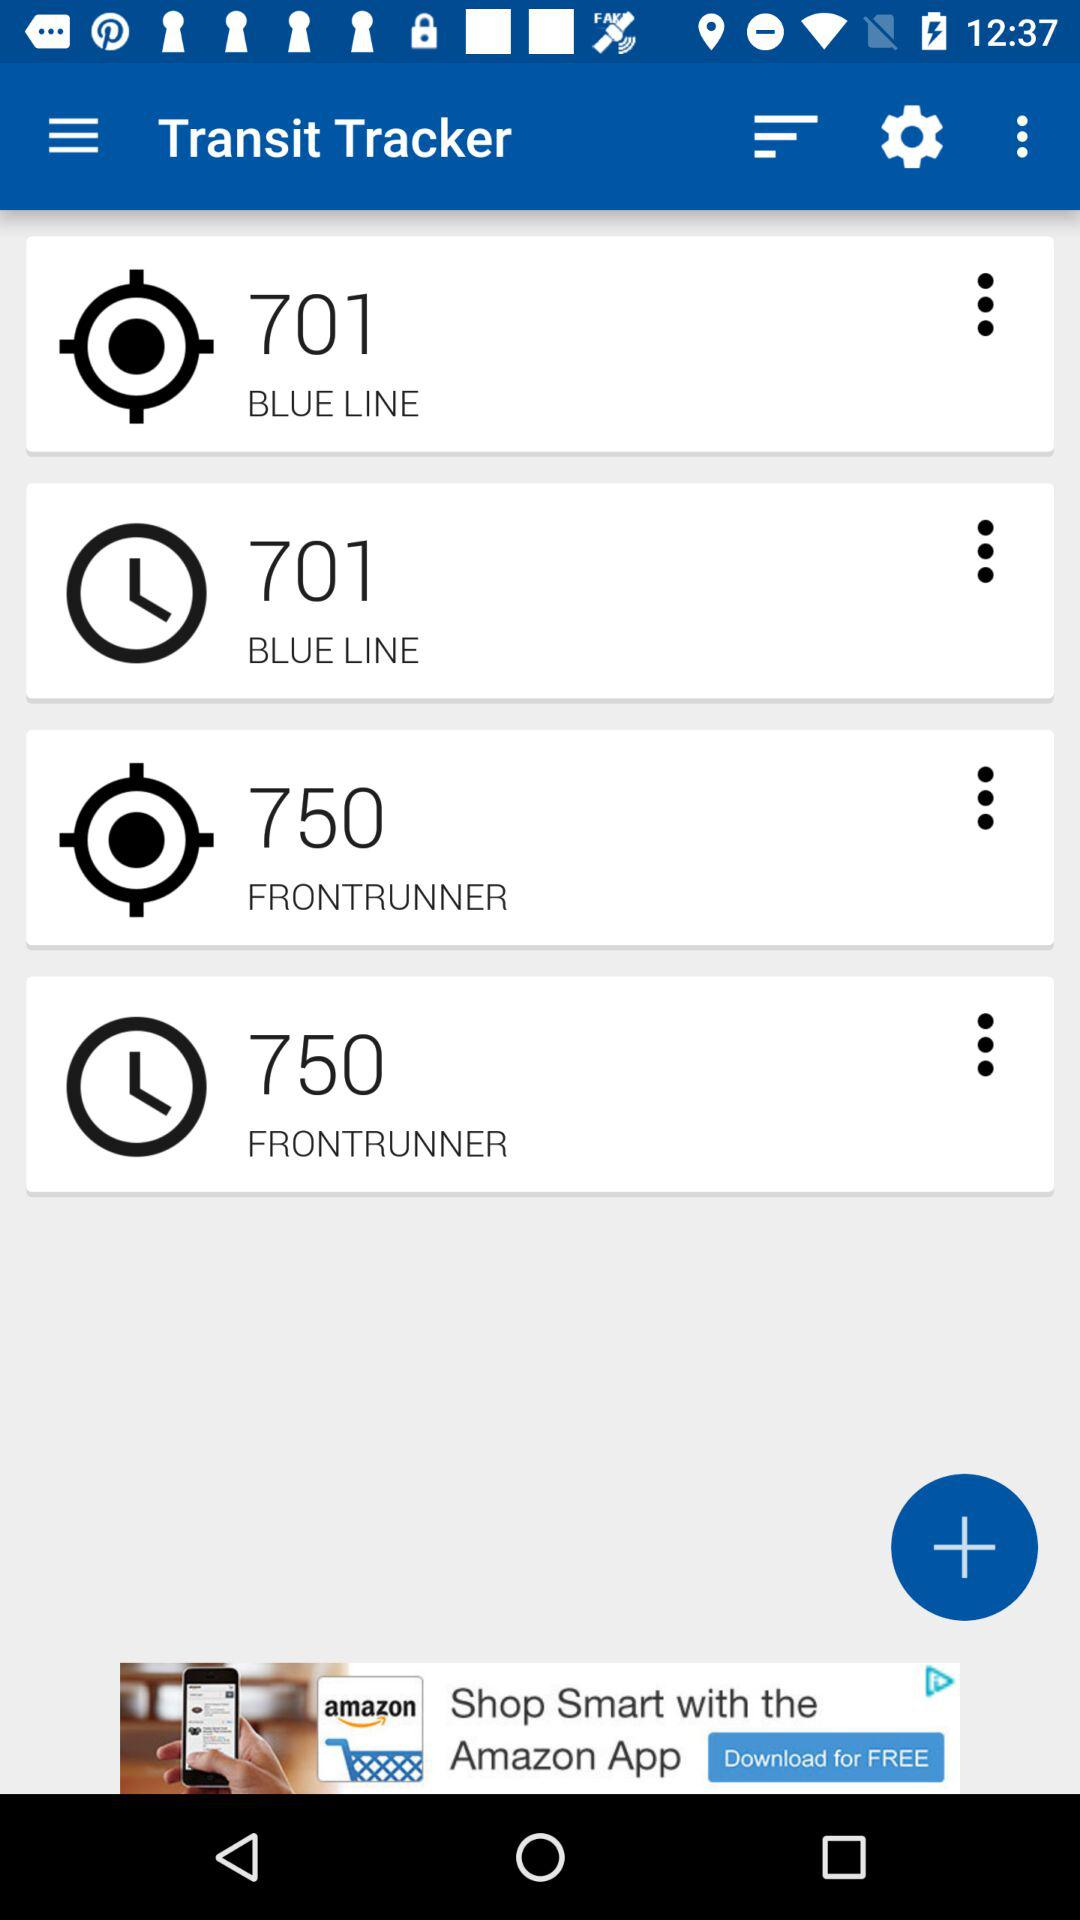What is the route number for "FRONTRUNNER"? The route number for "FRONTRUNNER" is 750. 